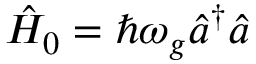Convert formula to latex. <formula><loc_0><loc_0><loc_500><loc_500>\hat { H } _ { 0 } = \hbar { \omega } _ { g } \hat { a } ^ { \dagger } \hat { a }</formula> 